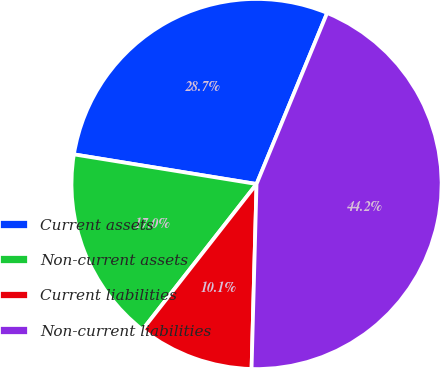<chart> <loc_0><loc_0><loc_500><loc_500><pie_chart><fcel>Current assets<fcel>Non-current assets<fcel>Current liabilities<fcel>Non-current liabilities<nl><fcel>28.67%<fcel>16.99%<fcel>10.14%<fcel>44.2%<nl></chart> 